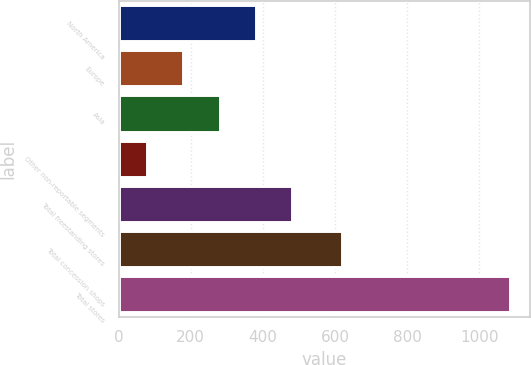Convert chart. <chart><loc_0><loc_0><loc_500><loc_500><bar_chart><fcel>North America<fcel>Europe<fcel>Asia<fcel>Other non-reportable segments<fcel>Total freestanding stores<fcel>Total concession shops<fcel>Total stores<nl><fcel>381.1<fcel>179.7<fcel>280.4<fcel>79<fcel>481.8<fcel>620<fcel>1086<nl></chart> 